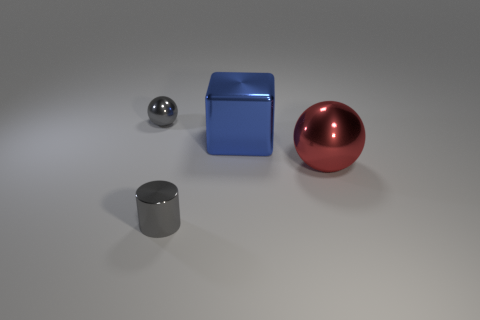Add 2 blue shiny blocks. How many objects exist? 6 Subtract all blocks. How many objects are left? 3 Add 4 tiny cylinders. How many tiny cylinders exist? 5 Subtract 0 green balls. How many objects are left? 4 Subtract all blue cubes. Subtract all tiny red rubber balls. How many objects are left? 3 Add 4 small gray cylinders. How many small gray cylinders are left? 5 